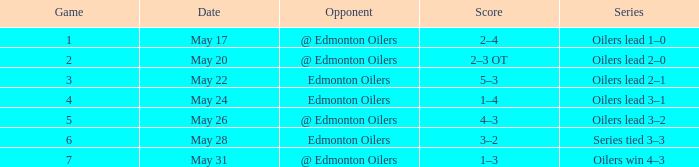What was the highest-scoring game in the series where the oilers won 4-3? 7.0. 